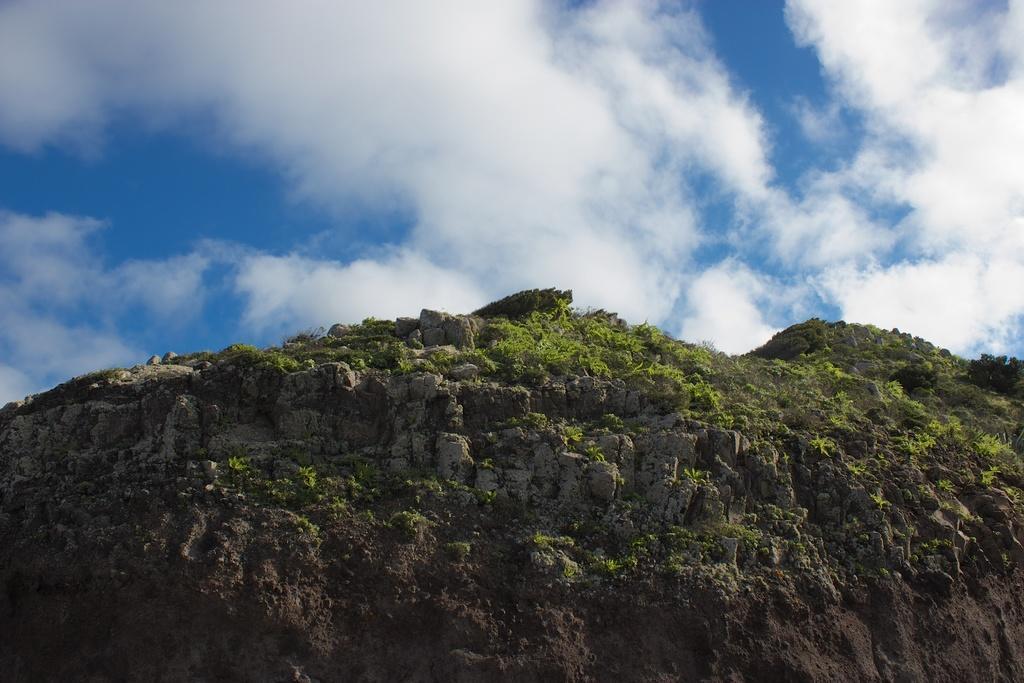How would you summarize this image in a sentence or two? In this image, we can see hills with rocks and plants. Background there is a cloudy sky. 